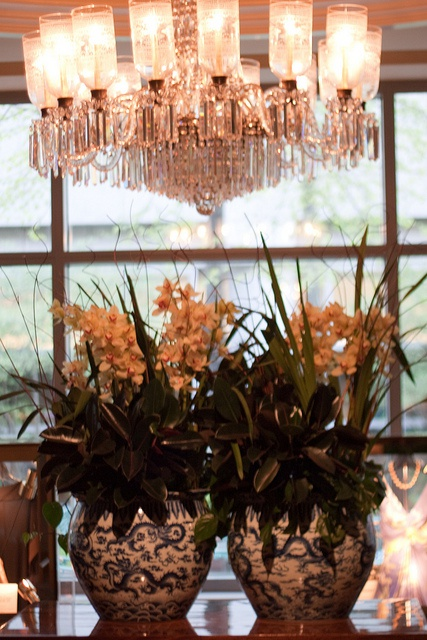Describe the objects in this image and their specific colors. I can see potted plant in salmon, black, maroon, and brown tones, potted plant in salmon, black, maroon, and brown tones, vase in salmon, black, maroon, and brown tones, and vase in salmon, black, maroon, and brown tones in this image. 